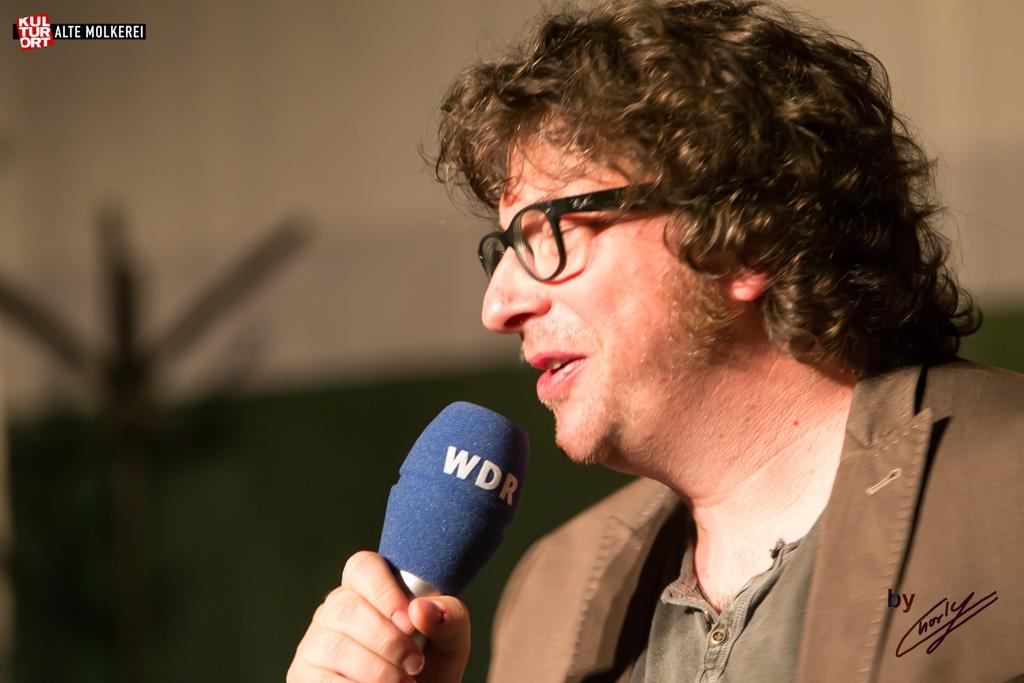Can you describe this image briefly? In this image I can see a man in front who is holding a mic and on the mic I can see 3 alphabets written. In the background I see that it is blurred and I can see the watermarks on the top left corner and bottom right corner of this picture. 